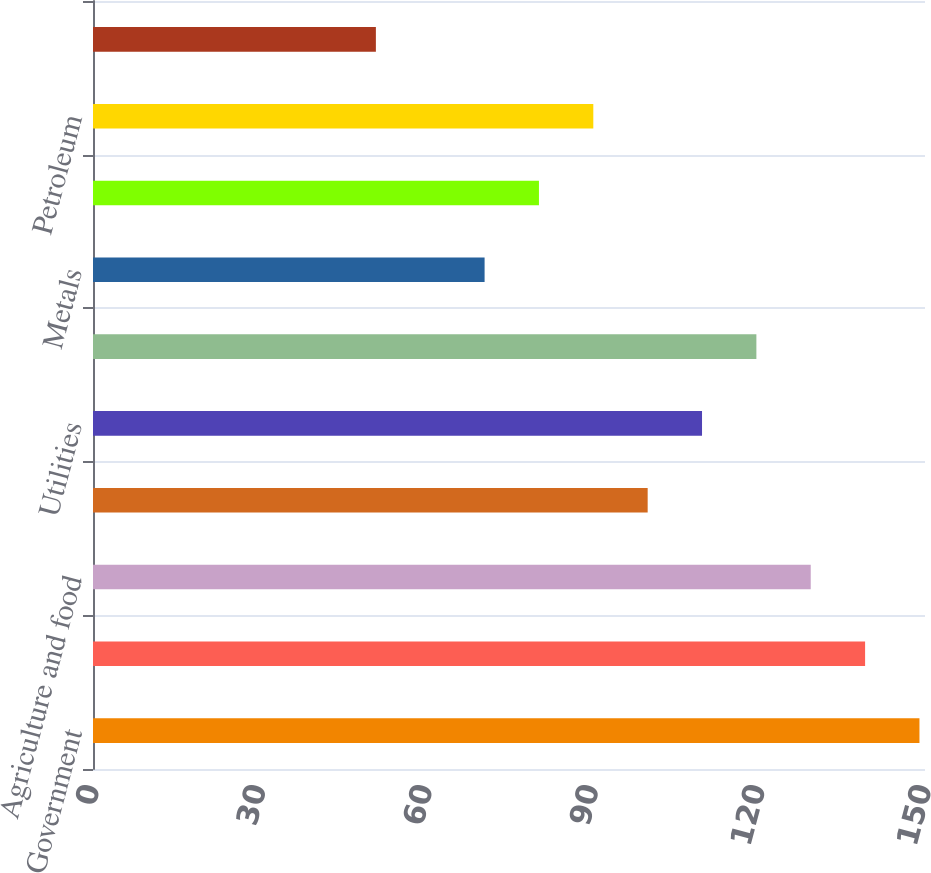<chart> <loc_0><loc_0><loc_500><loc_500><bar_chart><fcel>Government<fcel>Other financial institutions<fcel>Agriculture and food<fcel>Telephone and cable<fcel>Utilities<fcel>Autos<fcel>Metals<fcel>Chemicals<fcel>Petroleum<fcel>Retail<nl><fcel>149<fcel>139.2<fcel>129.4<fcel>100<fcel>109.8<fcel>119.6<fcel>70.6<fcel>80.4<fcel>90.2<fcel>51<nl></chart> 